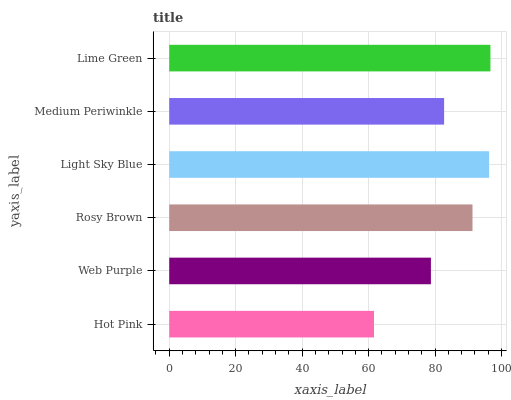Is Hot Pink the minimum?
Answer yes or no. Yes. Is Lime Green the maximum?
Answer yes or no. Yes. Is Web Purple the minimum?
Answer yes or no. No. Is Web Purple the maximum?
Answer yes or no. No. Is Web Purple greater than Hot Pink?
Answer yes or no. Yes. Is Hot Pink less than Web Purple?
Answer yes or no. Yes. Is Hot Pink greater than Web Purple?
Answer yes or no. No. Is Web Purple less than Hot Pink?
Answer yes or no. No. Is Rosy Brown the high median?
Answer yes or no. Yes. Is Medium Periwinkle the low median?
Answer yes or no. Yes. Is Hot Pink the high median?
Answer yes or no. No. Is Hot Pink the low median?
Answer yes or no. No. 